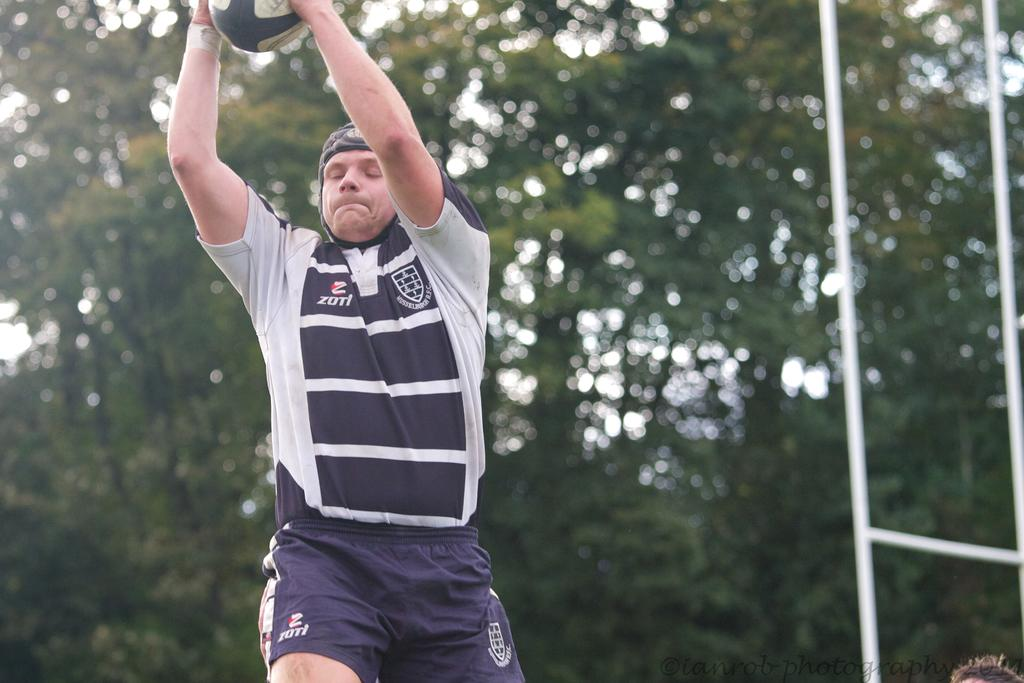What is the main subject of the image? There is a man in the image. What is the man doing in the image? The man is jumping in the air while holding a bowl. What can be seen on the right side of the image? There is a goal post on the right side of the image. What is visible in the background of the image? There are trees in the background of the image. What type of beam is supporting the man as he jumps in the image? There is no beam present in the image; the man is jumping in the air without any visible support. What time of day is it in the image, given the presence of metal objects? The presence of metal objects does not indicate the time of day in the image. The time of day cannot be determined from the image alone. 